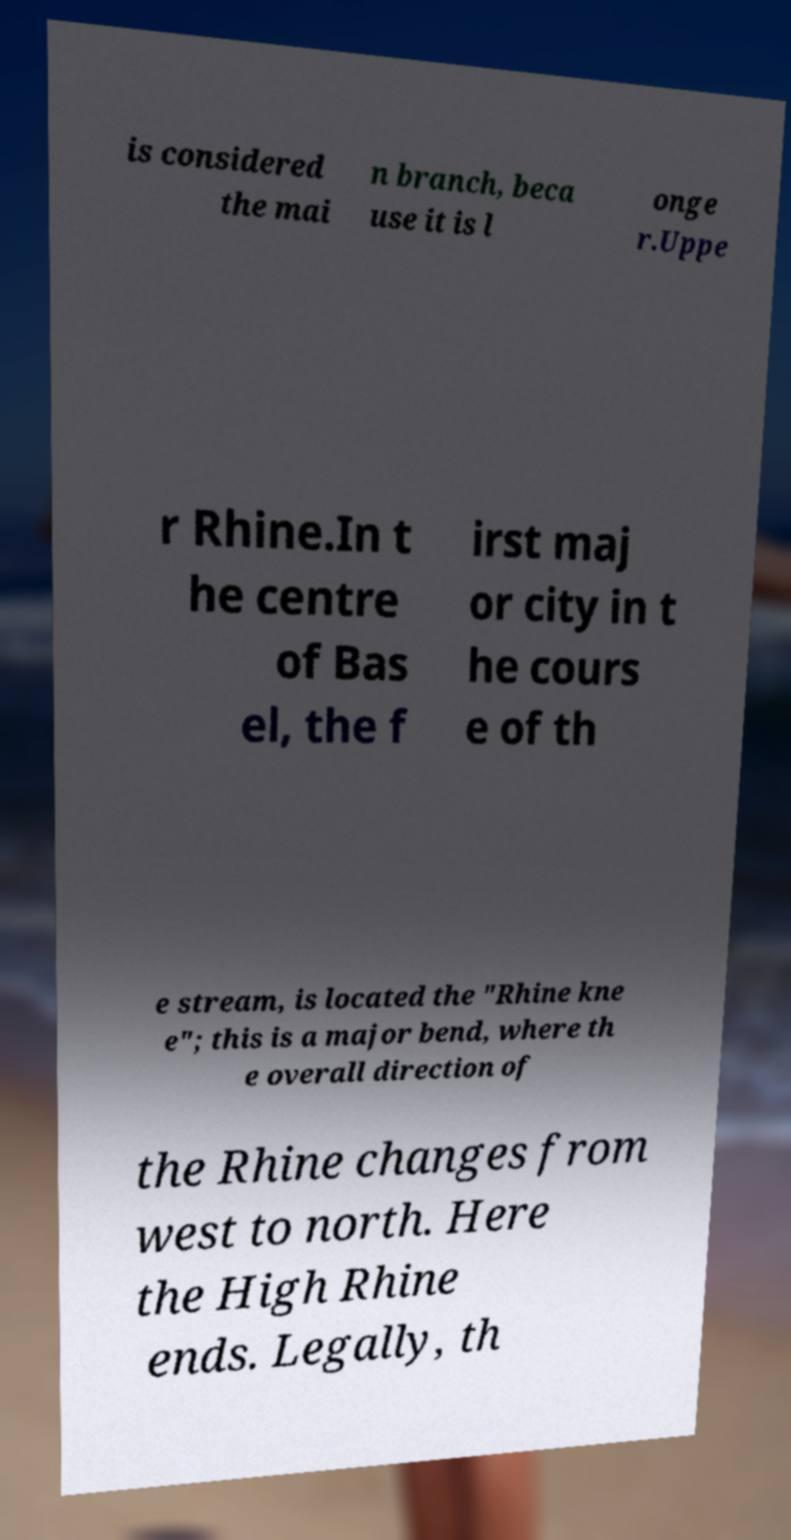For documentation purposes, I need the text within this image transcribed. Could you provide that? is considered the mai n branch, beca use it is l onge r.Uppe r Rhine.In t he centre of Bas el, the f irst maj or city in t he cours e of th e stream, is located the "Rhine kne e"; this is a major bend, where th e overall direction of the Rhine changes from west to north. Here the High Rhine ends. Legally, th 